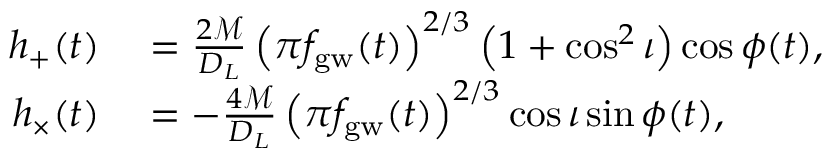Convert formula to latex. <formula><loc_0><loc_0><loc_500><loc_500>\begin{array} { r l } { h _ { + } ( t ) } & = \frac { 2 \mathcal { M } } { D _ { L } } \left ( \pi f _ { g w } ( t ) \right ) ^ { 2 / 3 } \left ( 1 + \cos ^ { 2 } \iota \right ) \cos { \phi ( t ) } , } \\ { h _ { \times } ( t ) } & = - \frac { 4 \mathcal { M } } { D _ { L } } \left ( \pi f _ { g w } ( t ) \right ) ^ { 2 / 3 } \cos { \iota } \sin { \phi ( t ) } , } \end{array}</formula> 